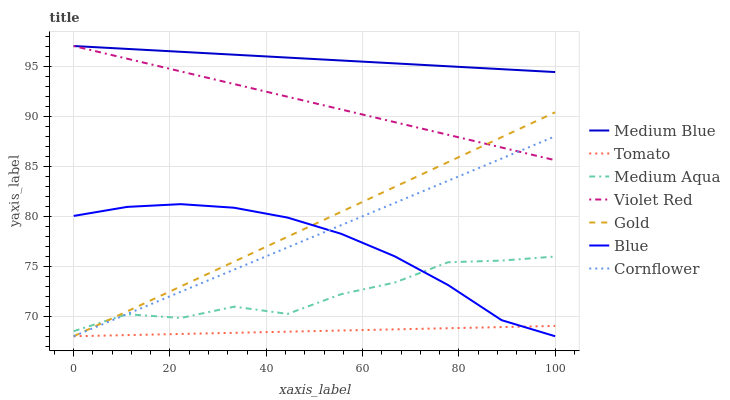Does Tomato have the minimum area under the curve?
Answer yes or no. Yes. Does Medium Blue have the maximum area under the curve?
Answer yes or no. Yes. Does Blue have the minimum area under the curve?
Answer yes or no. No. Does Blue have the maximum area under the curve?
Answer yes or no. No. Is Medium Blue the smoothest?
Answer yes or no. Yes. Is Medium Aqua the roughest?
Answer yes or no. Yes. Is Blue the smoothest?
Answer yes or no. No. Is Blue the roughest?
Answer yes or no. No. Does Violet Red have the lowest value?
Answer yes or no. No. Does Medium Blue have the highest value?
Answer yes or no. Yes. Does Blue have the highest value?
Answer yes or no. No. Is Tomato less than Medium Blue?
Answer yes or no. Yes. Is Medium Blue greater than Tomato?
Answer yes or no. Yes. Does Violet Red intersect Gold?
Answer yes or no. Yes. Is Violet Red less than Gold?
Answer yes or no. No. Is Violet Red greater than Gold?
Answer yes or no. No. Does Tomato intersect Medium Blue?
Answer yes or no. No. 